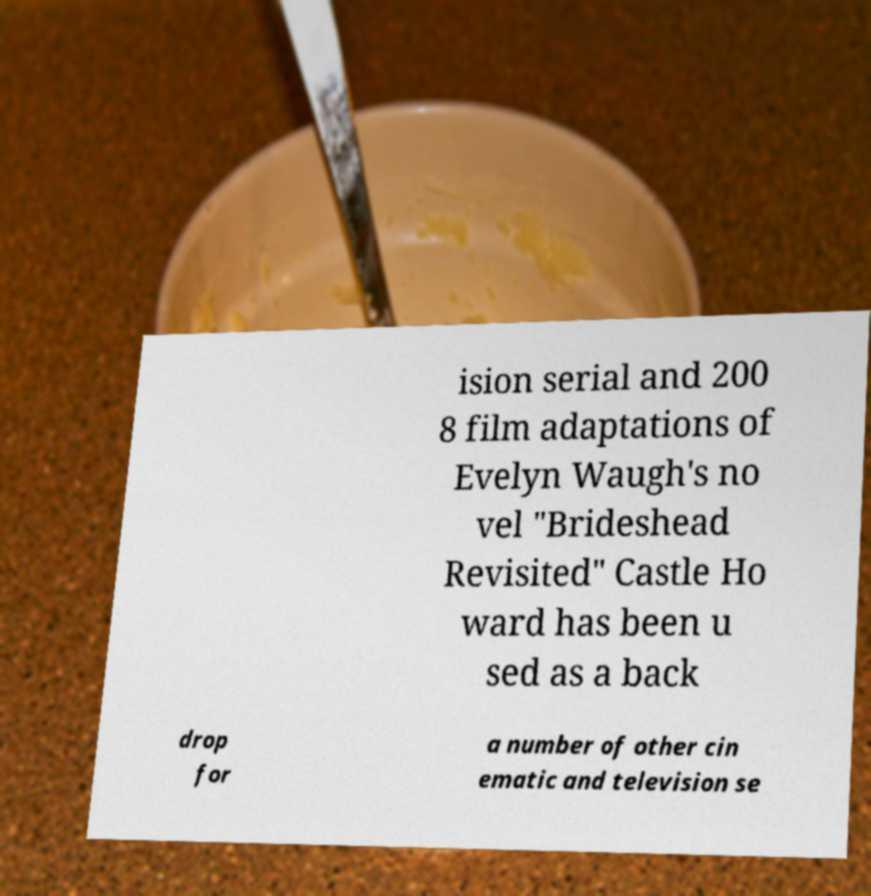Can you accurately transcribe the text from the provided image for me? ision serial and 200 8 film adaptations of Evelyn Waugh's no vel "Brideshead Revisited" Castle Ho ward has been u sed as a back drop for a number of other cin ematic and television se 